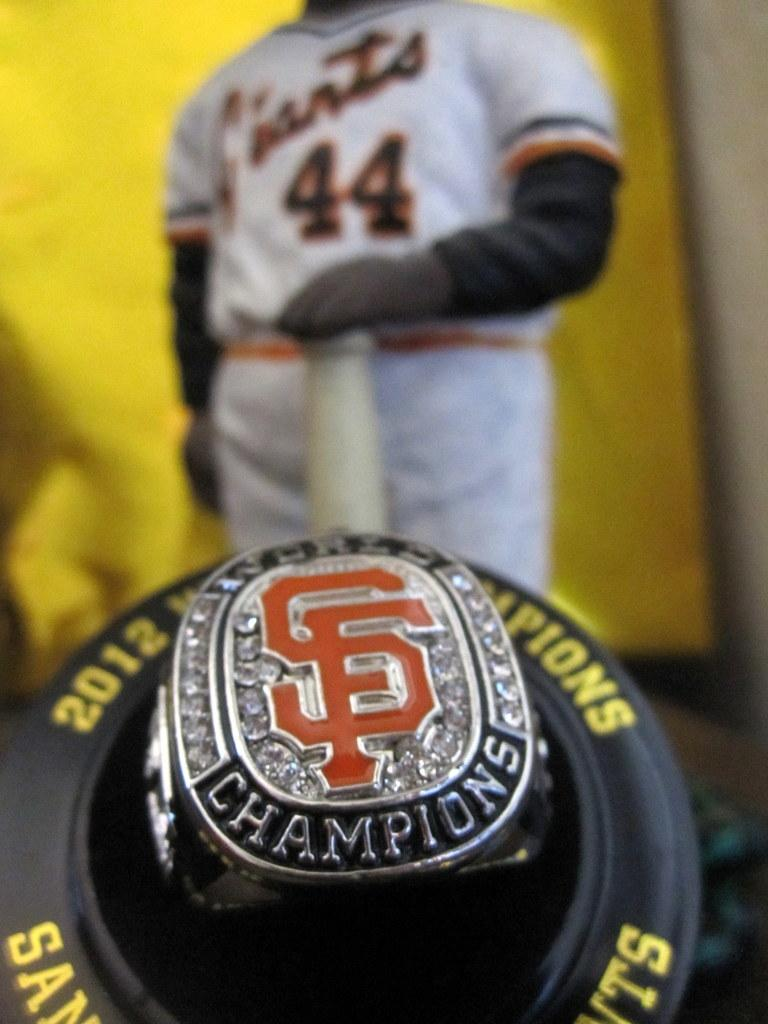<image>
Describe the image concisely. San Francisco Giants player #44 is standing behind a 2012 Championship ring 